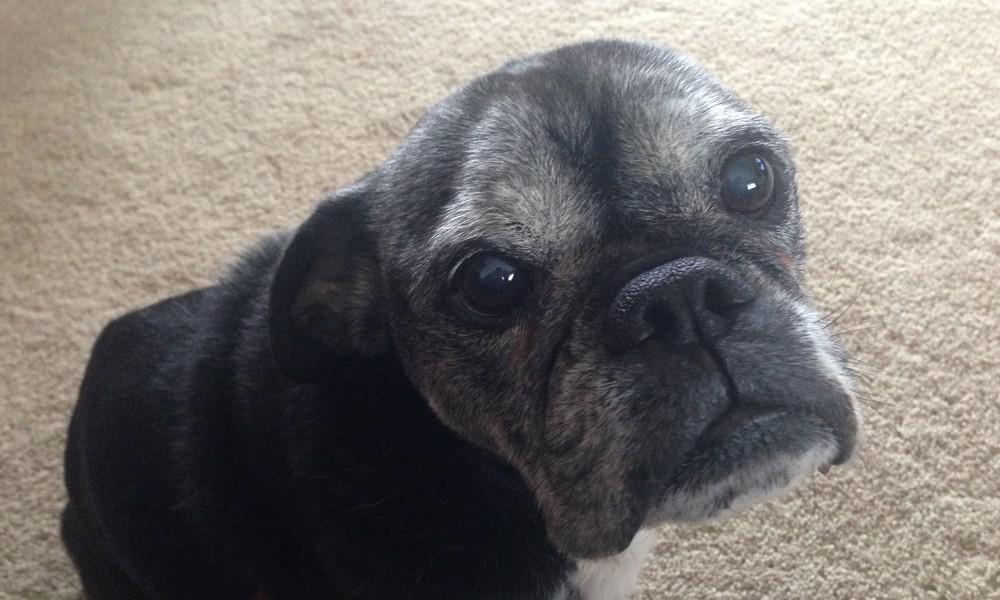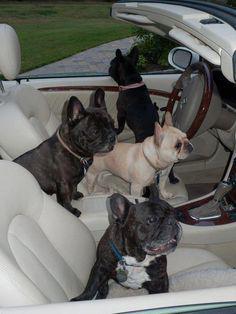The first image is the image on the left, the second image is the image on the right. Evaluate the accuracy of this statement regarding the images: "In one of the images the dog is wearing a hat.". Is it true? Answer yes or no. No. 